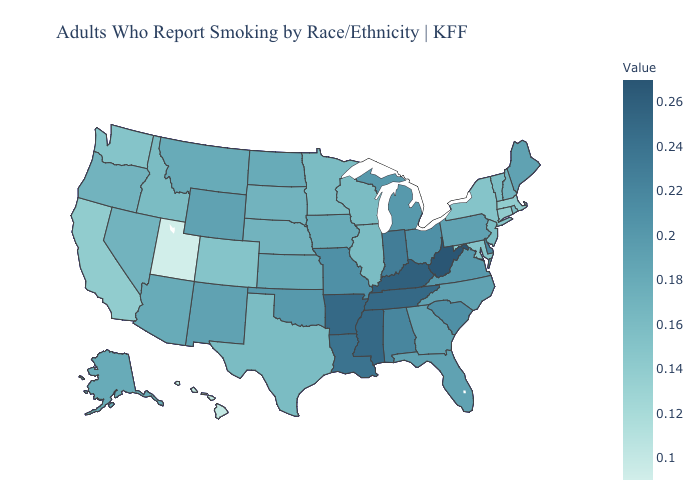Does South Dakota have the lowest value in the MidWest?
Quick response, please. No. Does West Virginia have the highest value in the USA?
Quick response, please. Yes. 